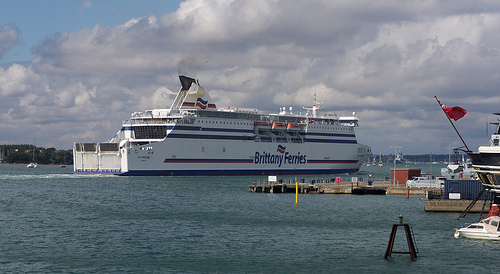Please provide the bounding box coordinate of the region this sentence describes: part of a blue sky. The bounding box coordinates for part of the blue sky are [0.02, 0.23, 0.33, 0.26]. 